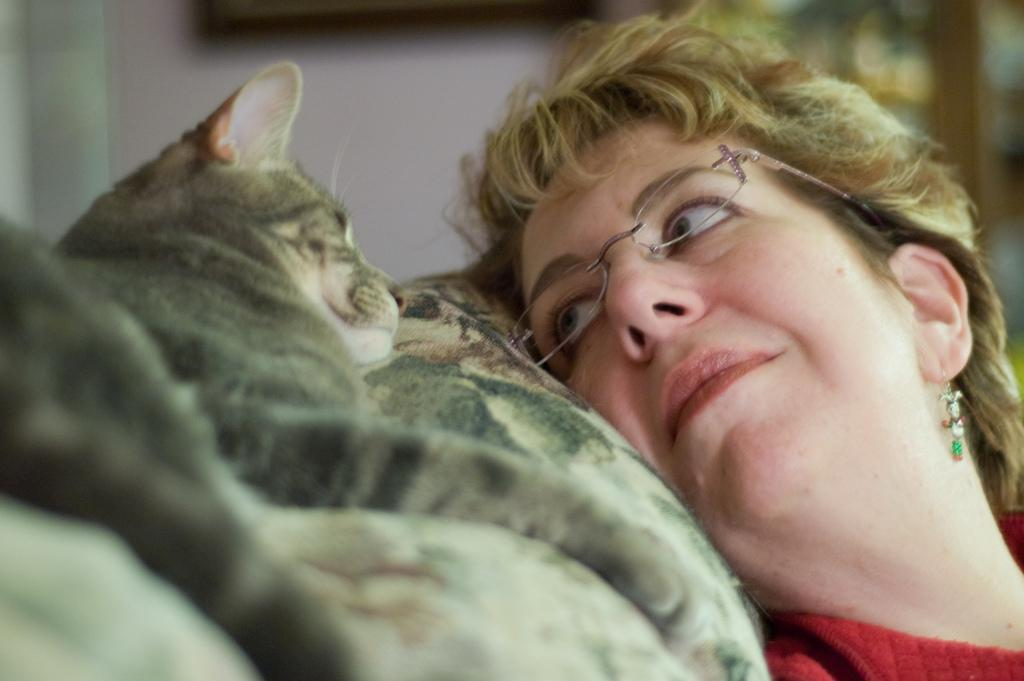What is the main subject of the image? There is a woman in the image. Are there any animals present in the image? Yes, there is a cat in the image. What grade does the woman receive for her performance in the library? There is no mention of a library or performance in the image, and therefore no grade can be assigned. 